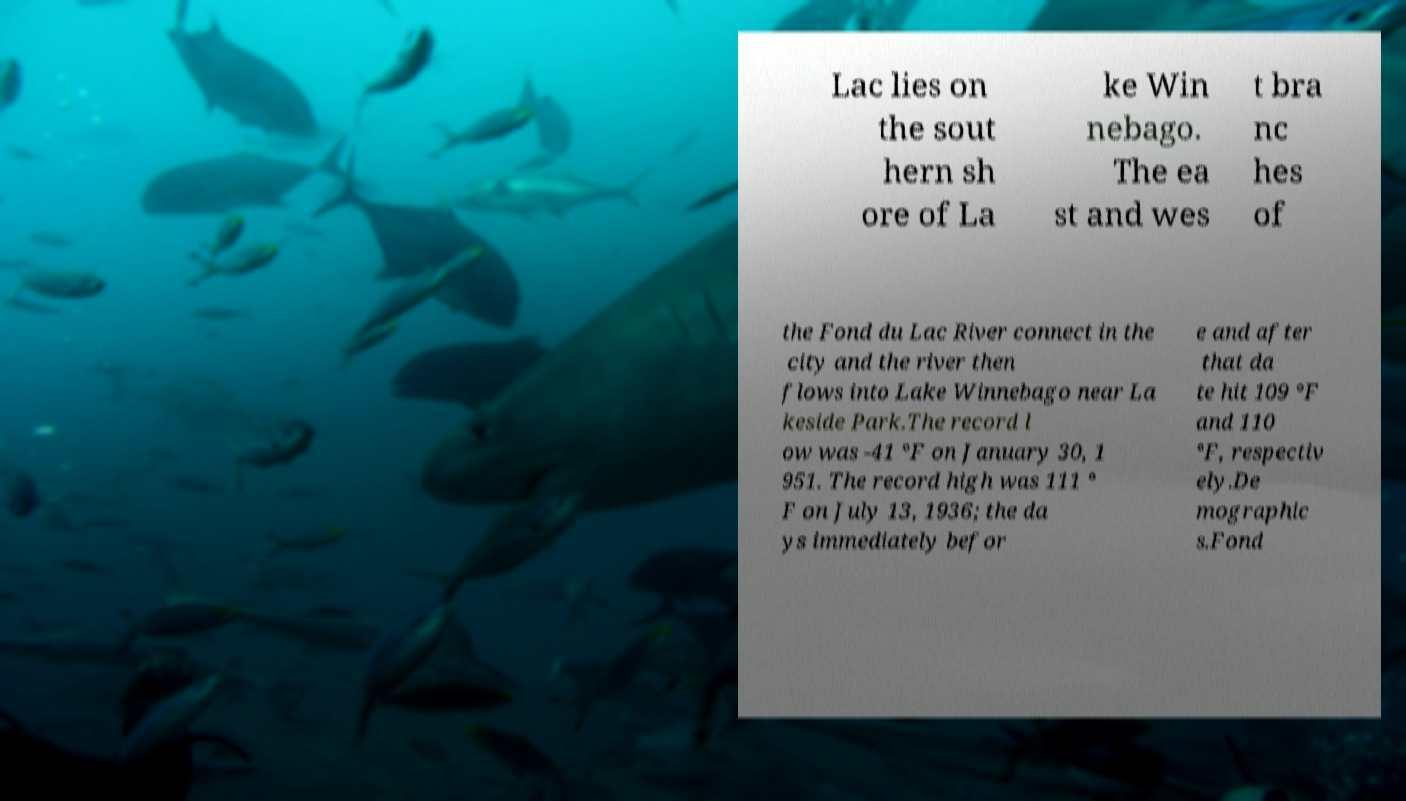For documentation purposes, I need the text within this image transcribed. Could you provide that? Lac lies on the sout hern sh ore of La ke Win nebago. The ea st and wes t bra nc hes of the Fond du Lac River connect in the city and the river then flows into Lake Winnebago near La keside Park.The record l ow was -41 °F on January 30, 1 951. The record high was 111 ° F on July 13, 1936; the da ys immediately befor e and after that da te hit 109 °F and 110 °F, respectiv ely.De mographic s.Fond 